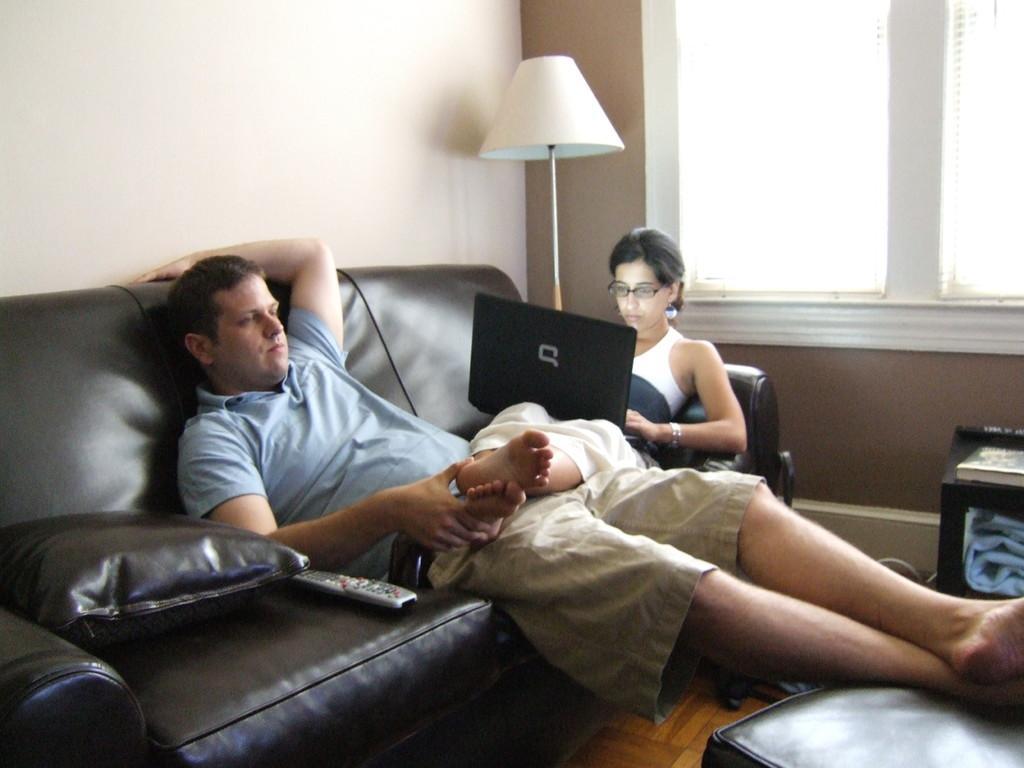Please provide a concise description of this image. In the image we can see there are people who are sitting on sofa. 